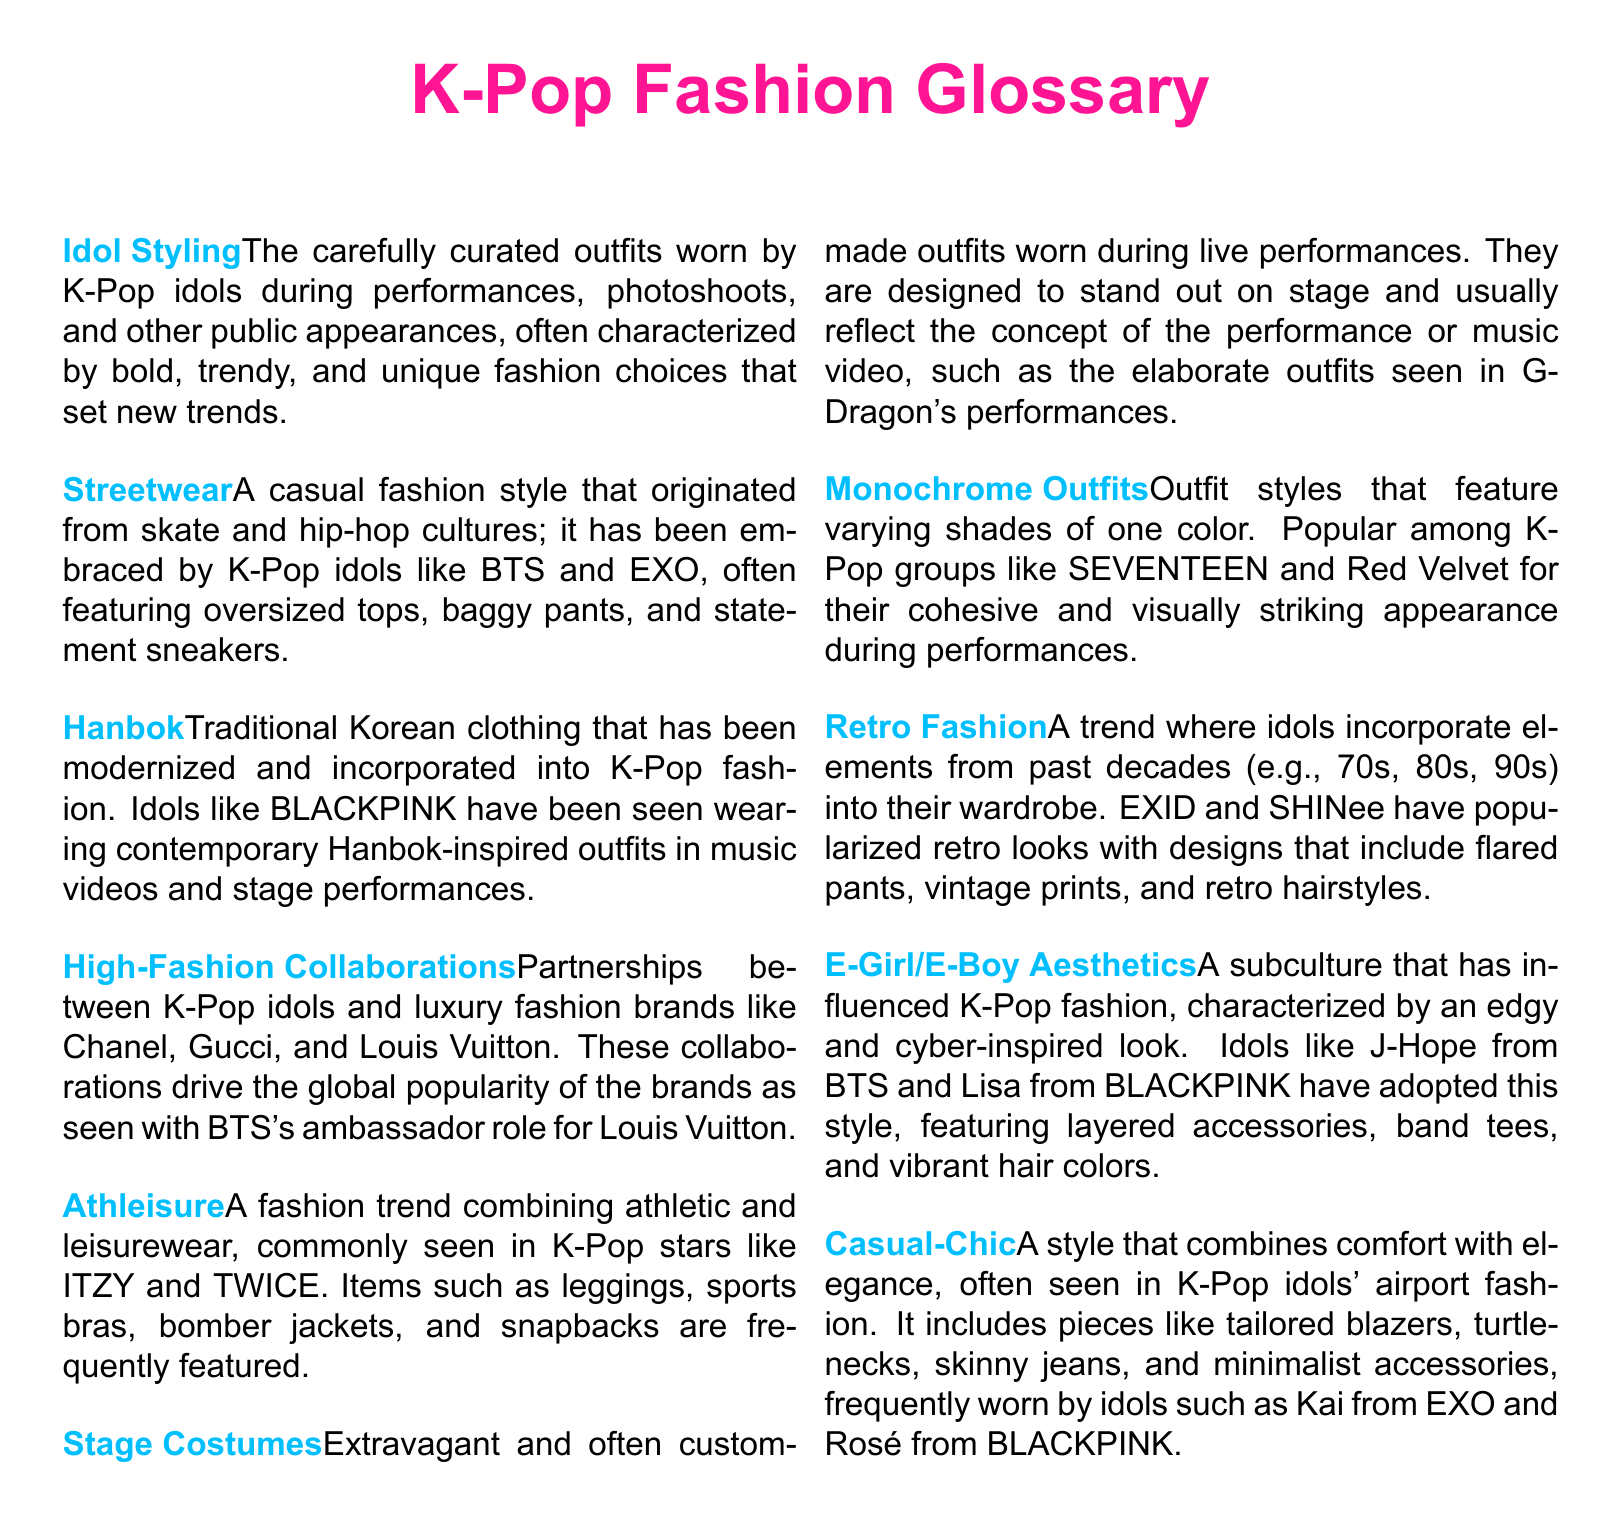What are the outfits worn by K-Pop idols during performances called? The document states these carefully curated outfits are referred to as "Idol Styling."
Answer: Idol Styling Which traditional Korean clothing is mentioned in the document? The document highlights "Hanbok" as the traditional Korean clothing modernized in K-Pop fashion.
Answer: Hanbok What fashion style combines athletic and leisurewear? This style is referred to as "Athleisure" in the document.
Answer: Athleisure Which K-Pop group is known for monochrome outfits? The document mentions "SEVENTEEN" as a K-Pop group popular for their monochrome outfits.
Answer: SEVENTEEN What are the extravagant outfits worn during live performances called? The document states these outfits are known as "Stage Costumes."
Answer: Stage Costumes Which two K-Pop groups have popularized retro fashion? The document cites "EXID" and "SHINee" as groups that have popularized retro fashion.
Answer: EXID and SHINee What type of aesthetics is characterized by an edgy and cyber-inspired look? The document mentions "E-Girl/E-Boy Aesthetics" as this type of look.
Answer: E-Girl/E-Boy Aesthetics What is "Casual-Chic" style primarily known for? The document describes "Casual-Chic" as a style that combines comfort with elegance.
Answer: Comfort with elegance How do K-Pop idols influence global fashion trends according to the document? The document indicates through "High-Fashion Collaborations" with luxury brands, K-Pop idols influence fashion trends.
Answer: High-Fashion Collaborations 